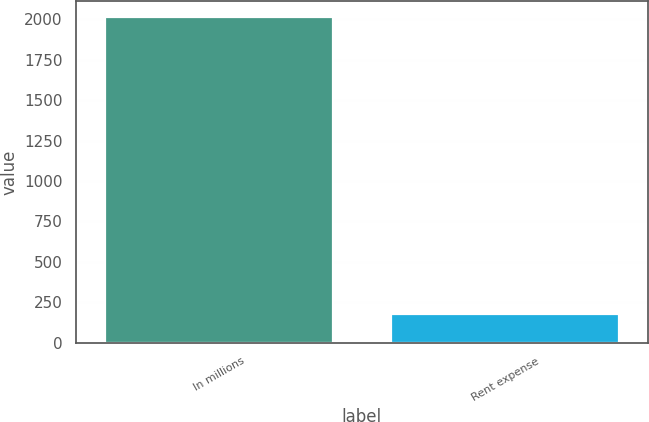Convert chart. <chart><loc_0><loc_0><loc_500><loc_500><bar_chart><fcel>In millions<fcel>Rent expense<nl><fcel>2012<fcel>176<nl></chart> 